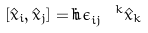Convert formula to latex. <formula><loc_0><loc_0><loc_500><loc_500>[ \hat { x } _ { i } , \hat { x } _ { j } ] = i \hbar { \epsilon } _ { i j } ^ { \ \ k } \hat { x } _ { k }</formula> 